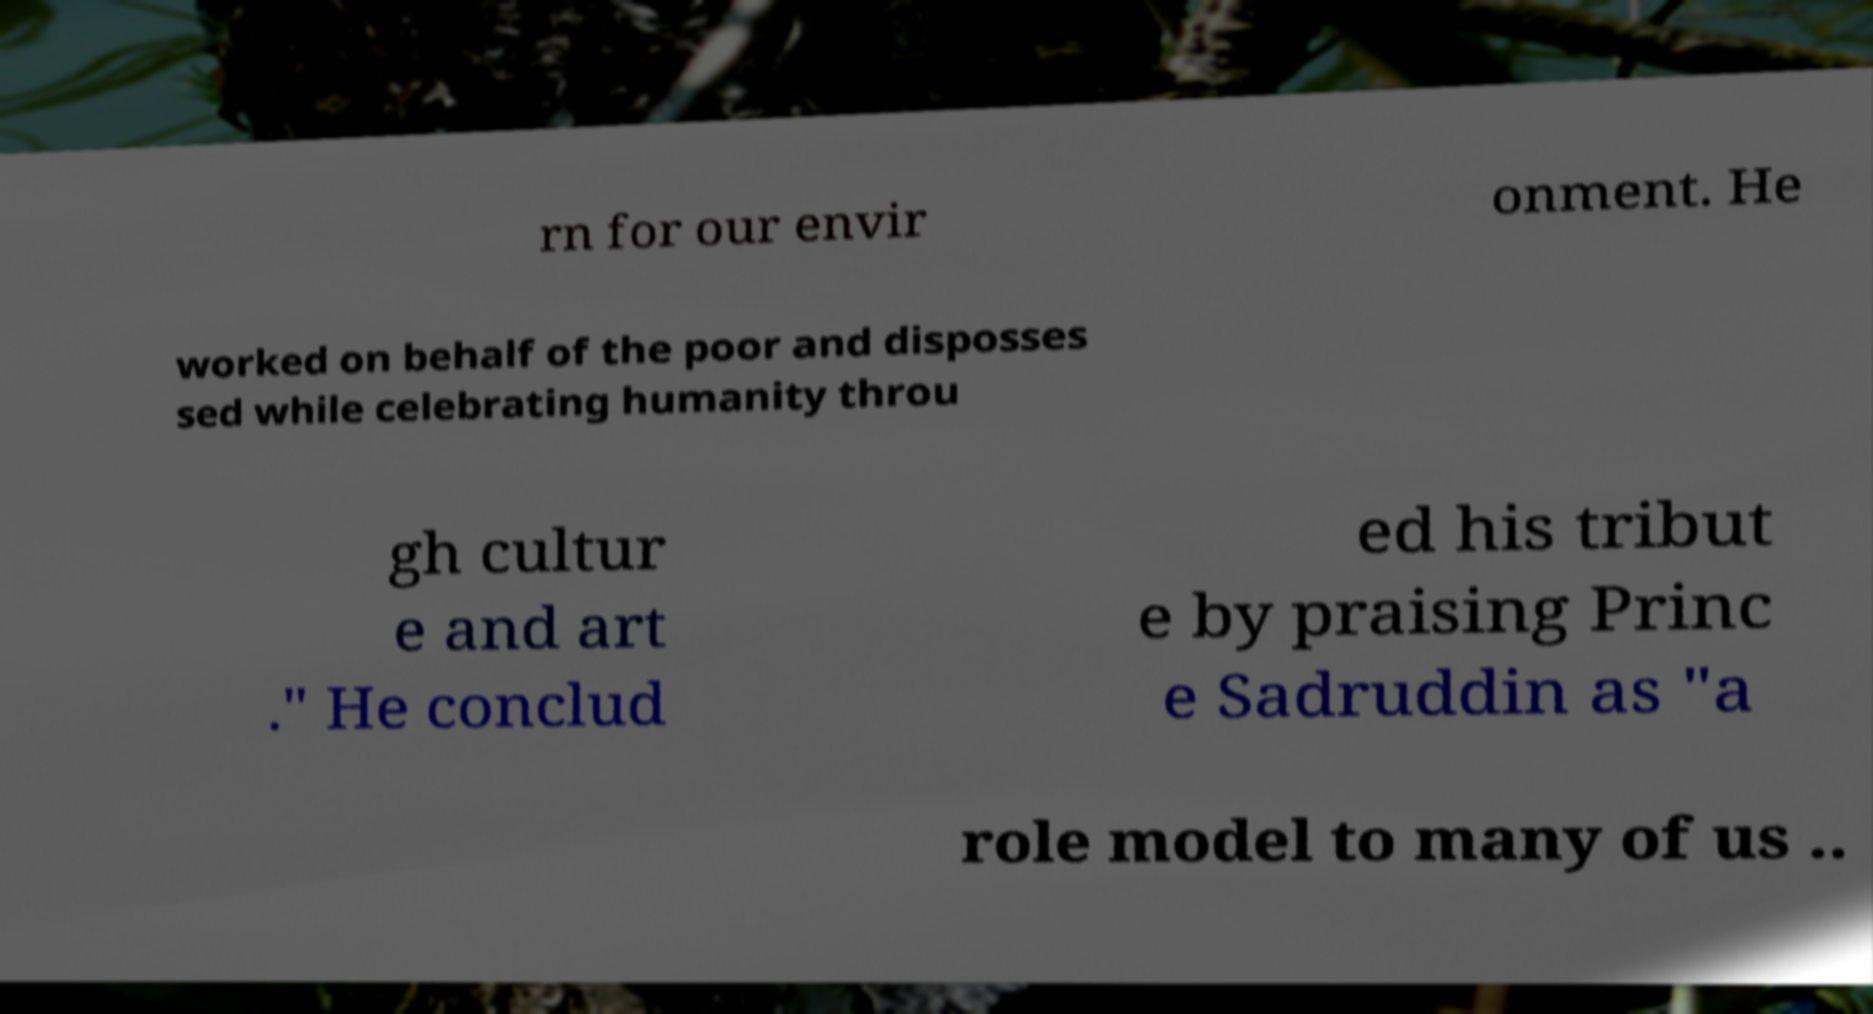There's text embedded in this image that I need extracted. Can you transcribe it verbatim? rn for our envir onment. He worked on behalf of the poor and disposses sed while celebrating humanity throu gh cultur e and art ." He conclud ed his tribut e by praising Princ e Sadruddin as "a role model to many of us .. 